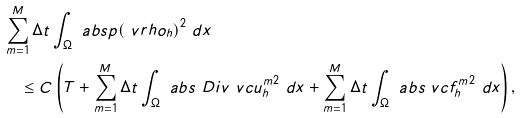Convert formula to latex. <formula><loc_0><loc_0><loc_500><loc_500>& \sum _ { m = 1 } ^ { M } \Delta t \int _ { \Omega } \ a b s { p ( \ v r h o _ { h } ) } ^ { 2 } \ d x \\ & \quad \leq C \left ( T + \sum _ { m = 1 } ^ { M } \Delta t \int _ { \Omega } \ a b s { \ D i v \ v c { u } _ { h } ^ { m } } ^ { 2 } \ d x + \sum _ { m = 1 } ^ { M } \Delta t \int _ { \Omega } \ a b s { \ v c { f } _ { h } ^ { m } } ^ { 2 } \ d x \right ) ,</formula> 